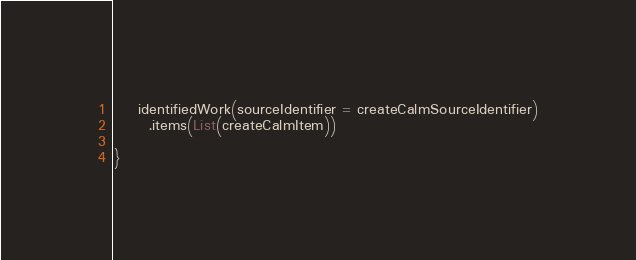<code> <loc_0><loc_0><loc_500><loc_500><_Scala_>    identifiedWork(sourceIdentifier = createCalmSourceIdentifier)
      .items(List(createCalmItem))

}
</code> 